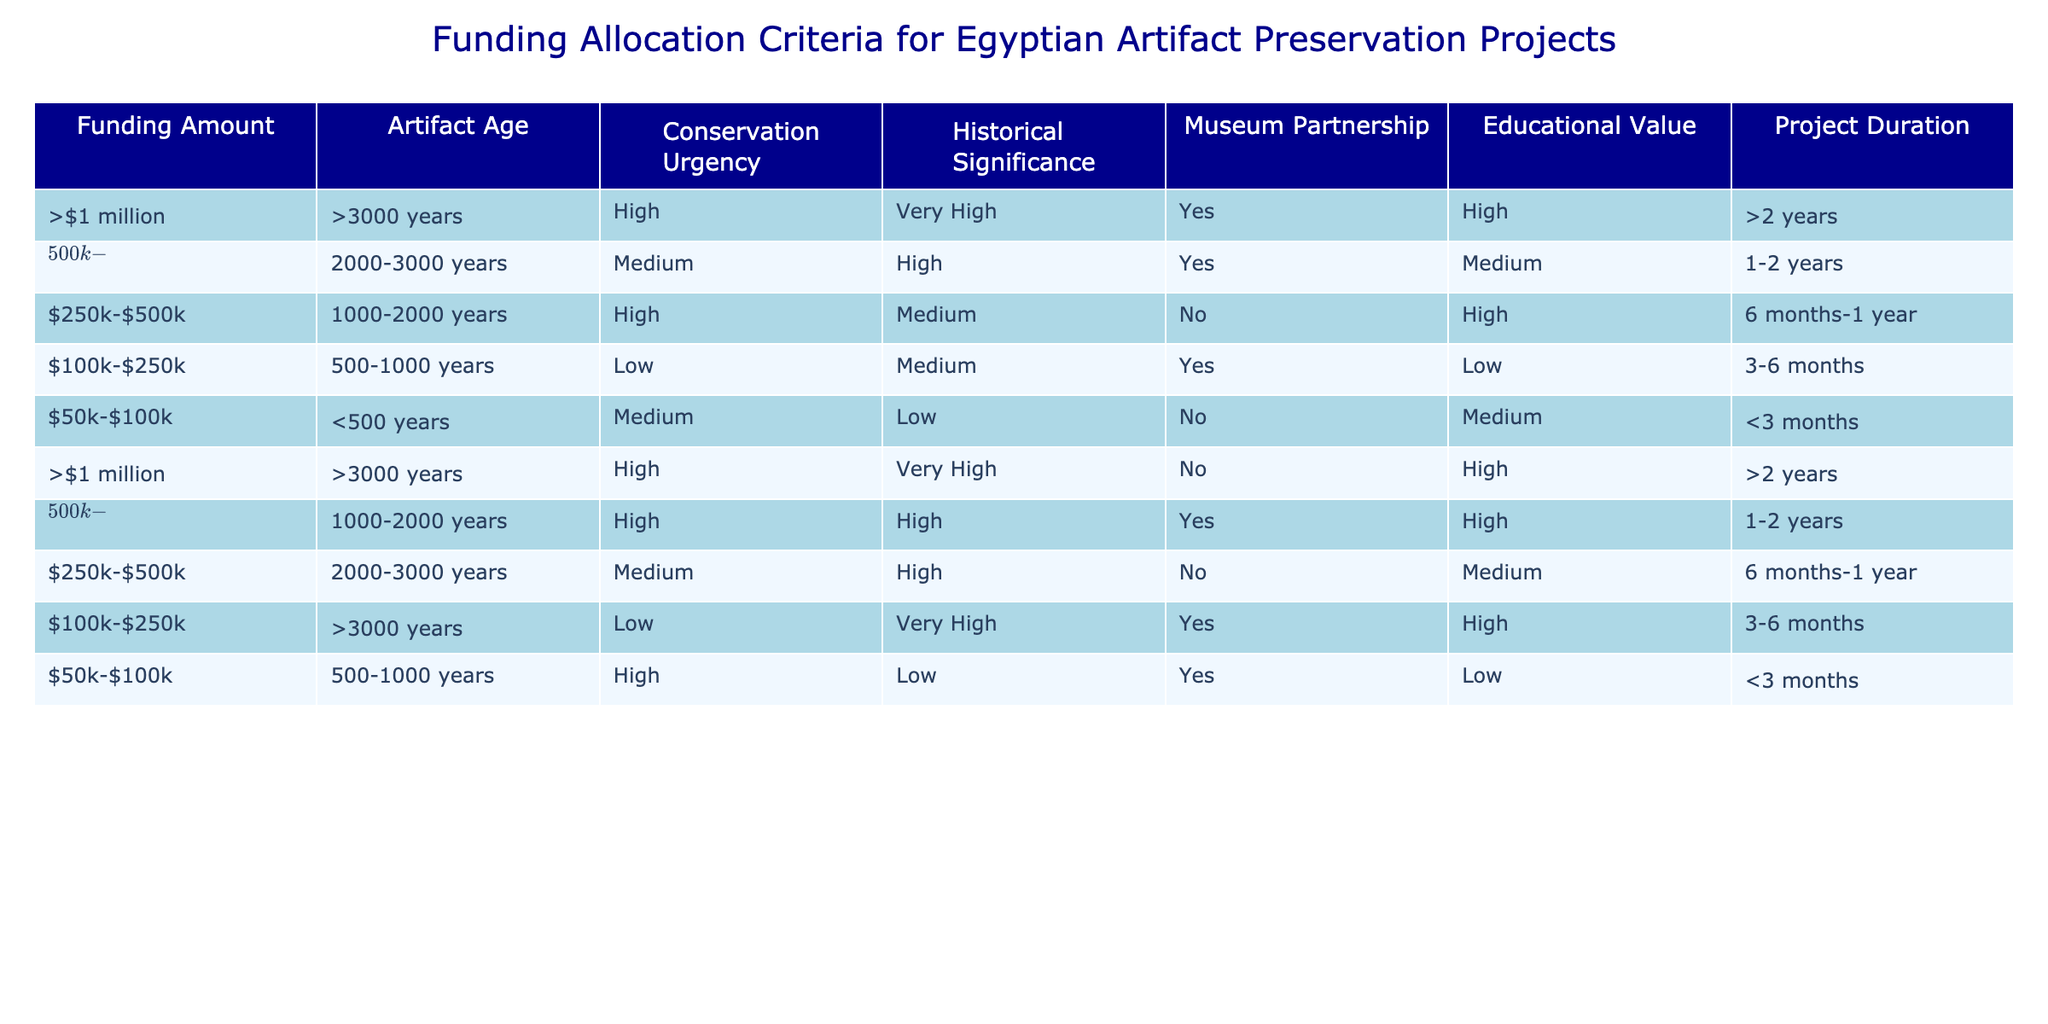What is the funding amount for projects that need high conservation urgency for artifacts older than 3000 years? From the table, there are two entries that meet the criteria: one is more than $1 million with high conservation urgency and the other is also more than $1 million with high conservation urgency but does not have a museum partnership. Both entries have the same funding amount.
Answer: More than $1 million Which project duration category is associated with artifacts aged between 1000 and 2000 years and has medium educational value? There is one entry for artifacts aged between 1000 and 2000 years with medium educational value, which falls into the project duration category of 1-2 years.
Answer: 1-2 years Are there any projects with a funding amount between $250k and $500k that lack a museum partnership? There is one such project listed: it is for artifacts aged between 2000 and 3000 years with medium conservation urgency and a historical significance of high. Thus, the answer is yes.
Answer: Yes What is the average age of artifacts for projects that are associated with high educational value? The projects associated with high educational value are for artifacts aged >3000 years (2 projects), 1000-2000 years (1 project), and also 500-1000 years (1 project). To find the average, we convert these age categories to approximate values: >3000 can be considered 3000, 1000 is 1000, and 500 is 500. The sum of these ages is approximately 500 + 1000 + 3000 = 4500, and there are 4 projects, so the average age is 4500/4 = 1125 years.
Answer: 1125 How many projects require low conservation urgency and are tied to a museum partnership? There are two projects: one for artifacts aged between 500-1000 years and the other for artifacts over 3000 years. Therefore, the total number is 2.
Answer: 2 